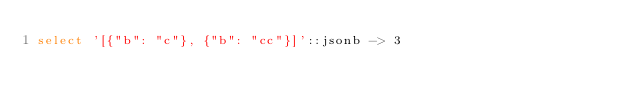<code> <loc_0><loc_0><loc_500><loc_500><_SQL_>select '[{"b": "c"}, {"b": "cc"}]'::jsonb -> 3
</code> 